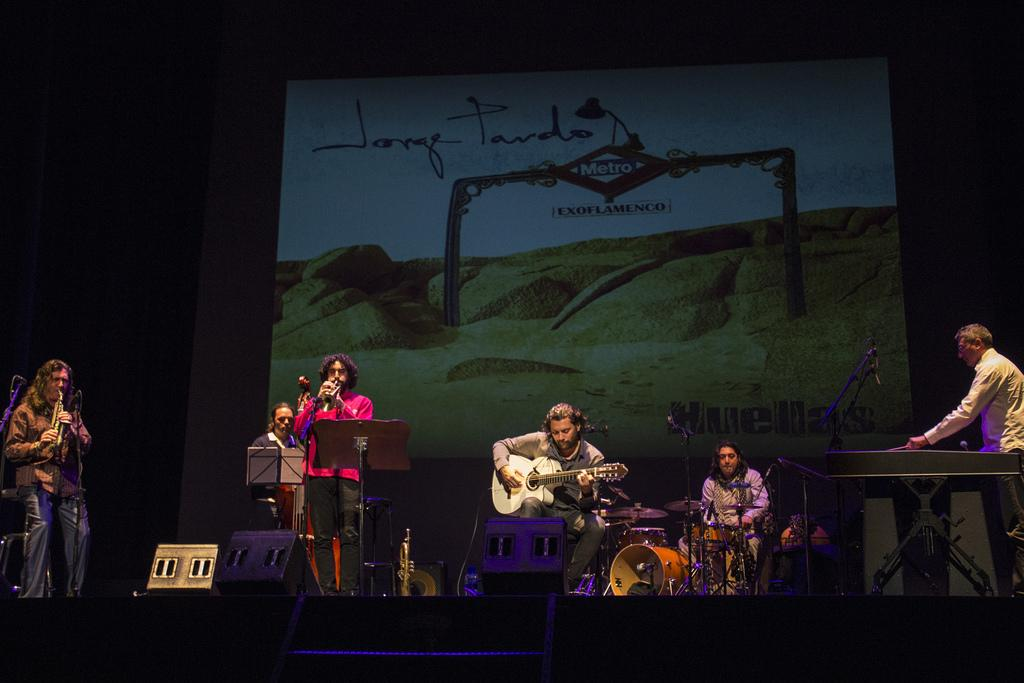What are the people in the image doing? The persons in the image are playing musical instruments. Where are the people playing their instruments? The group of persons is on a stage. What can be inferred about the setting of the image? The presence of a stage suggests that the people are performing in front of an audience. What type of thread is being used to create the melody in the image? There is no thread present in the image, and musical instruments do not create melodies using thread. 